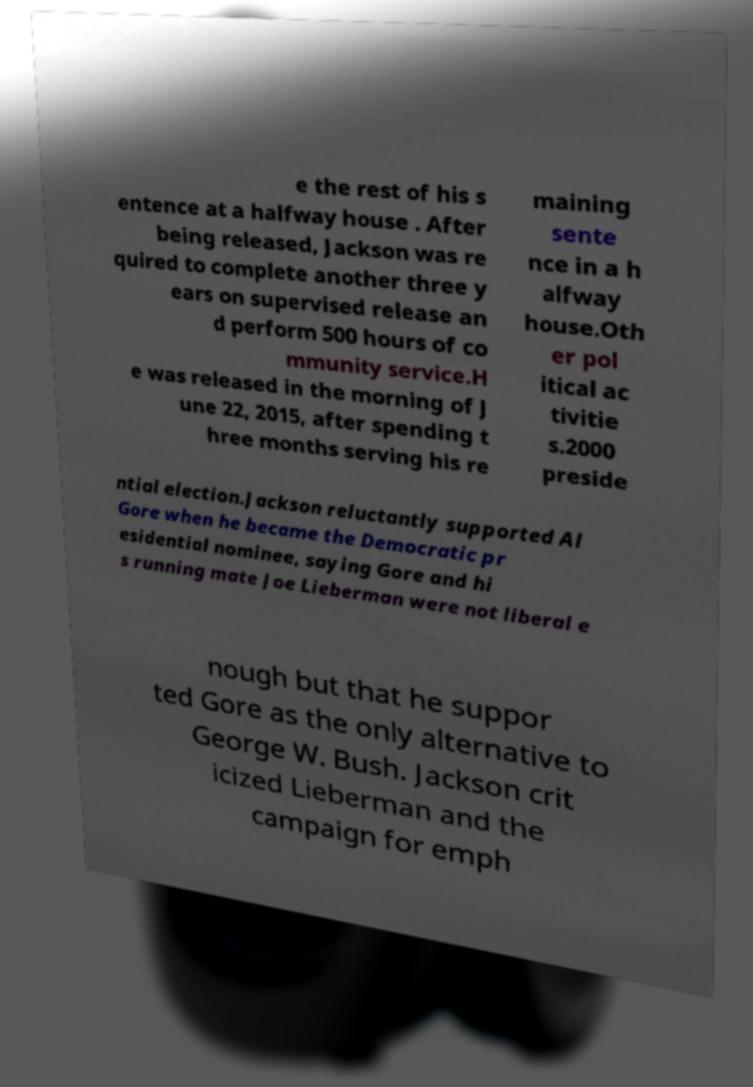Can you read and provide the text displayed in the image?This photo seems to have some interesting text. Can you extract and type it out for me? e the rest of his s entence at a halfway house . After being released, Jackson was re quired to complete another three y ears on supervised release an d perform 500 hours of co mmunity service.H e was released in the morning of J une 22, 2015, after spending t hree months serving his re maining sente nce in a h alfway house.Oth er pol itical ac tivitie s.2000 preside ntial election.Jackson reluctantly supported Al Gore when he became the Democratic pr esidential nominee, saying Gore and hi s running mate Joe Lieberman were not liberal e nough but that he suppor ted Gore as the only alternative to George W. Bush. Jackson crit icized Lieberman and the campaign for emph 